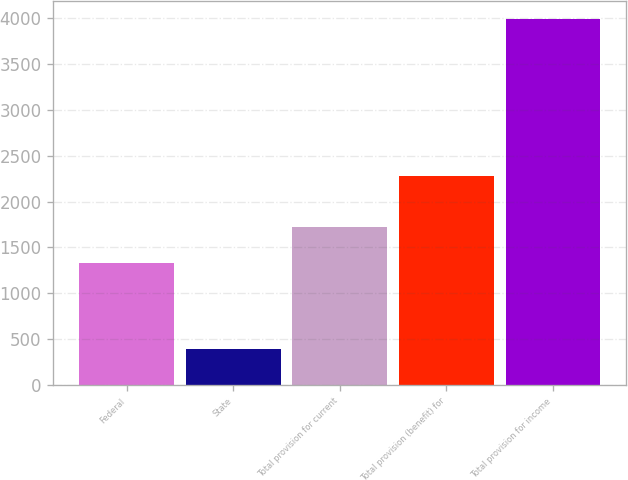Convert chart. <chart><loc_0><loc_0><loc_500><loc_500><bar_chart><fcel>Federal<fcel>State<fcel>Total provision for current<fcel>Total provision (benefit) for<fcel>Total provision for income<nl><fcel>1330<fcel>388<fcel>1718<fcel>2275<fcel>3993<nl></chart> 